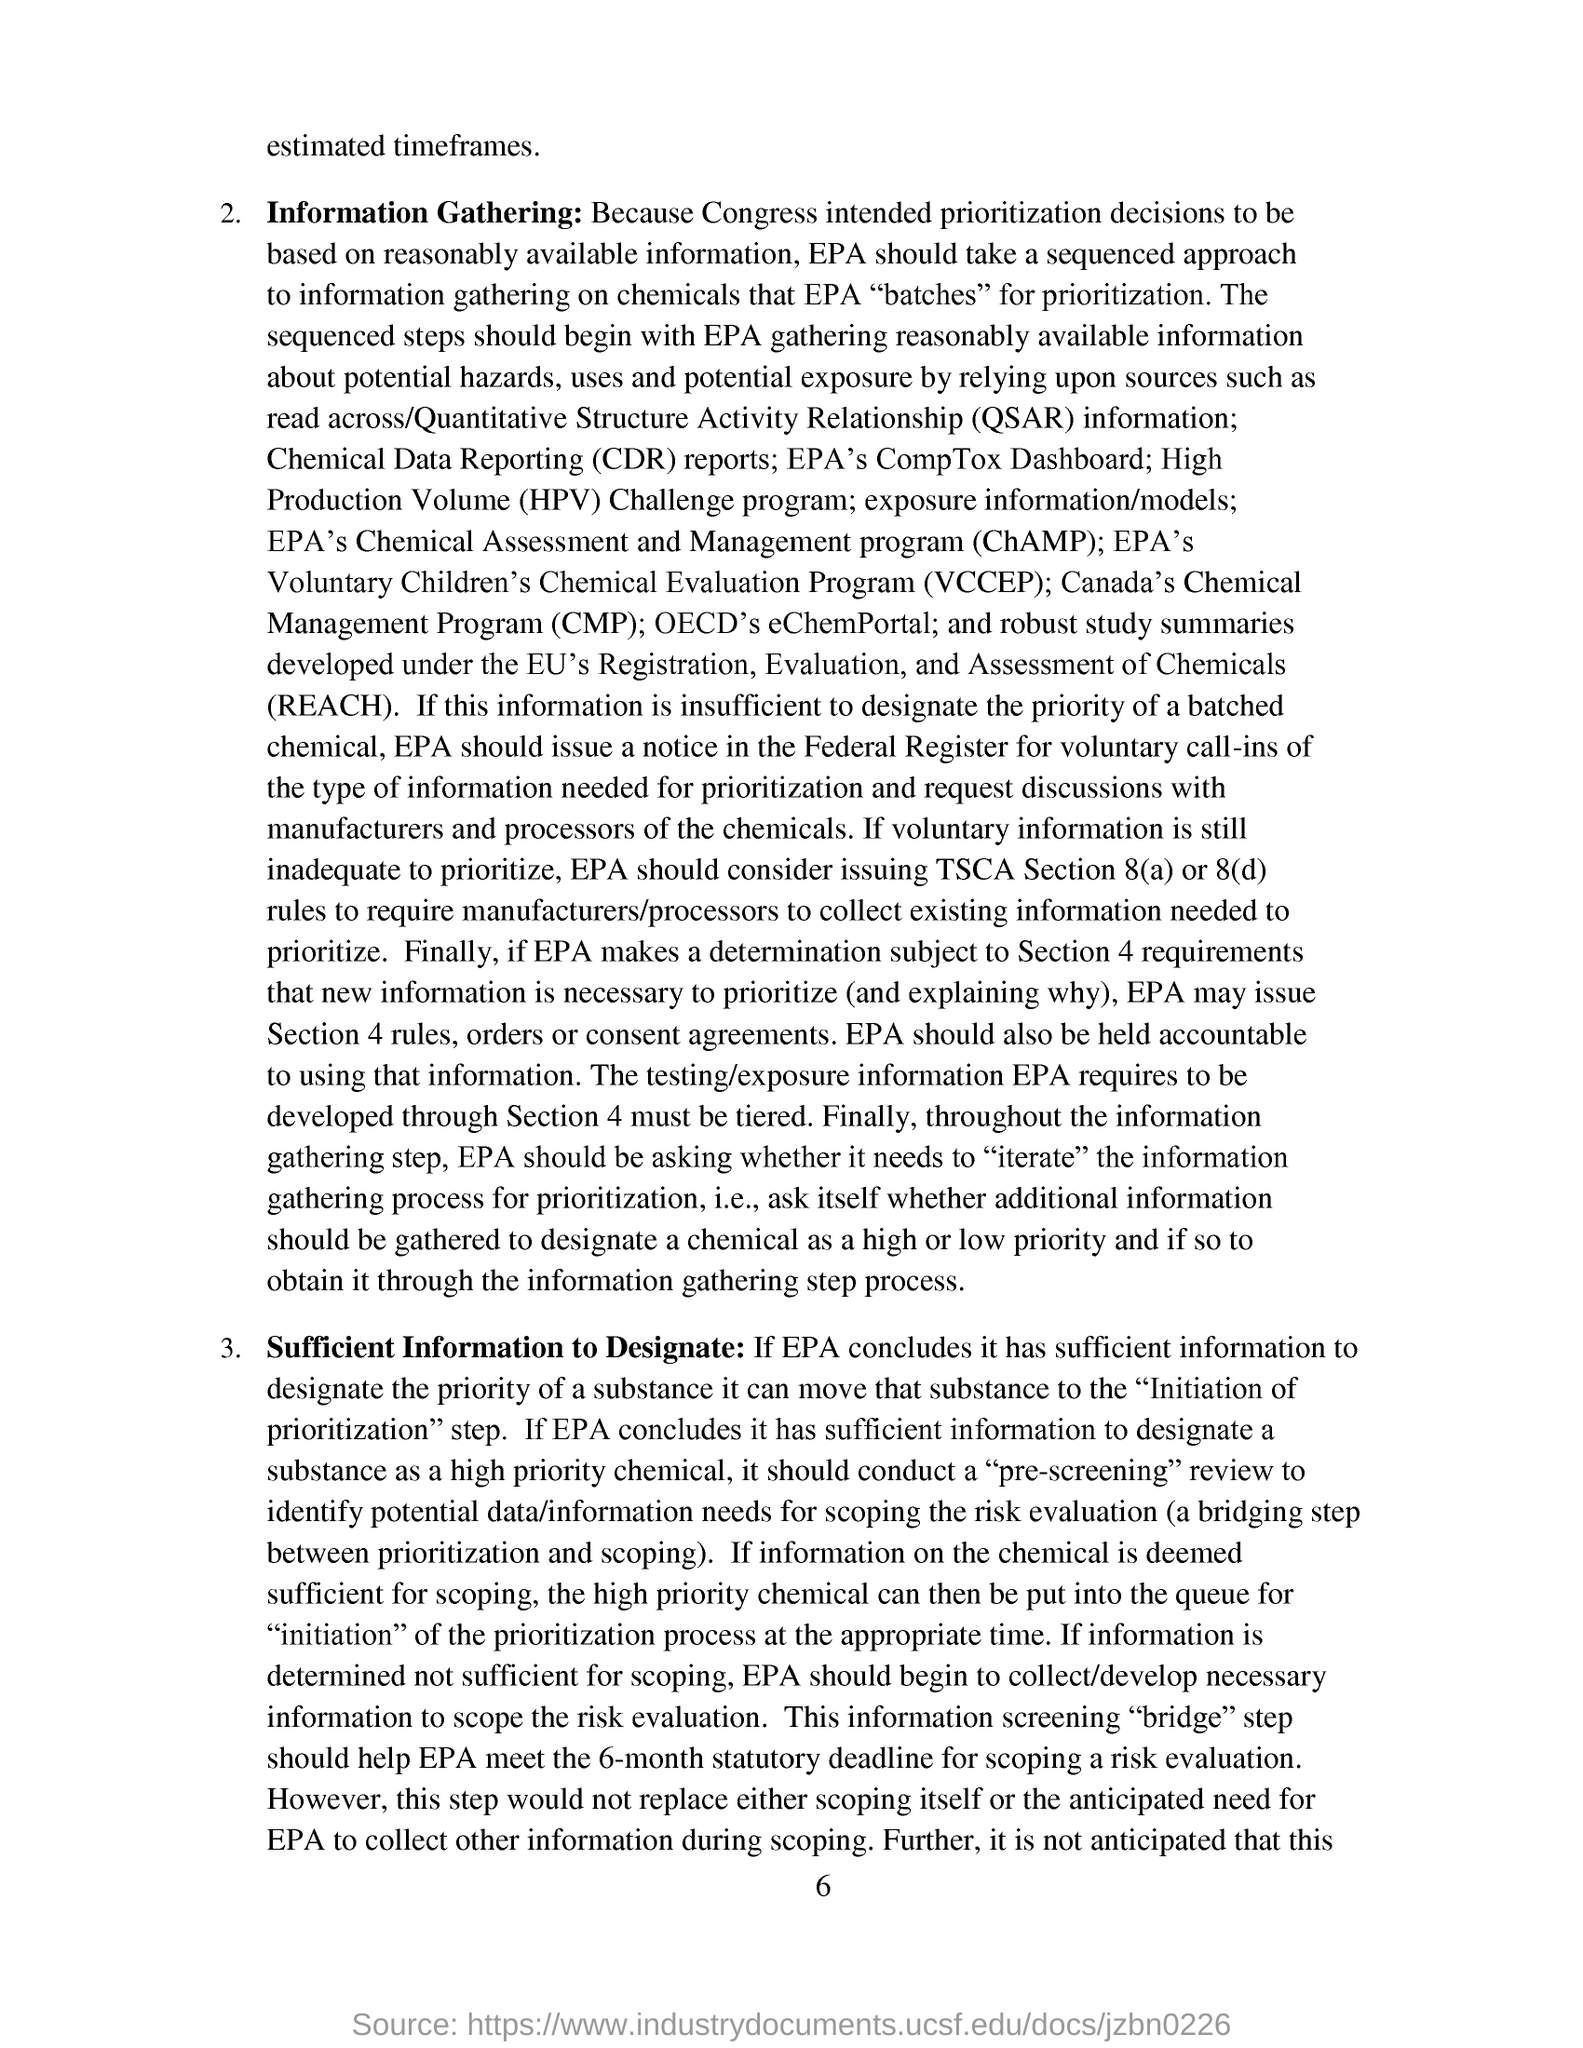Indicate a few pertinent items in this graphic. Quantitative structure-activity relationship, commonly abbreviated as QSAR, refers to a method of predicting the biological activity of a chemical compound using mathematical models that take into account both the chemical structure and the physical properties of the compound. These models are used to establish a relationship between the chemical structure of a compound and its biological activity, allowing researchers to make predictions about the activity of new compounds without having to perform time-consuming and expensive experiments. 